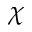Convert formula to latex. <formula><loc_0><loc_0><loc_500><loc_500>\chi</formula> 